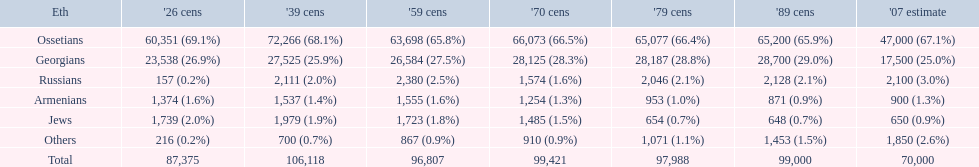How many ethnicities were below 1,000 people in 2007? 2. 